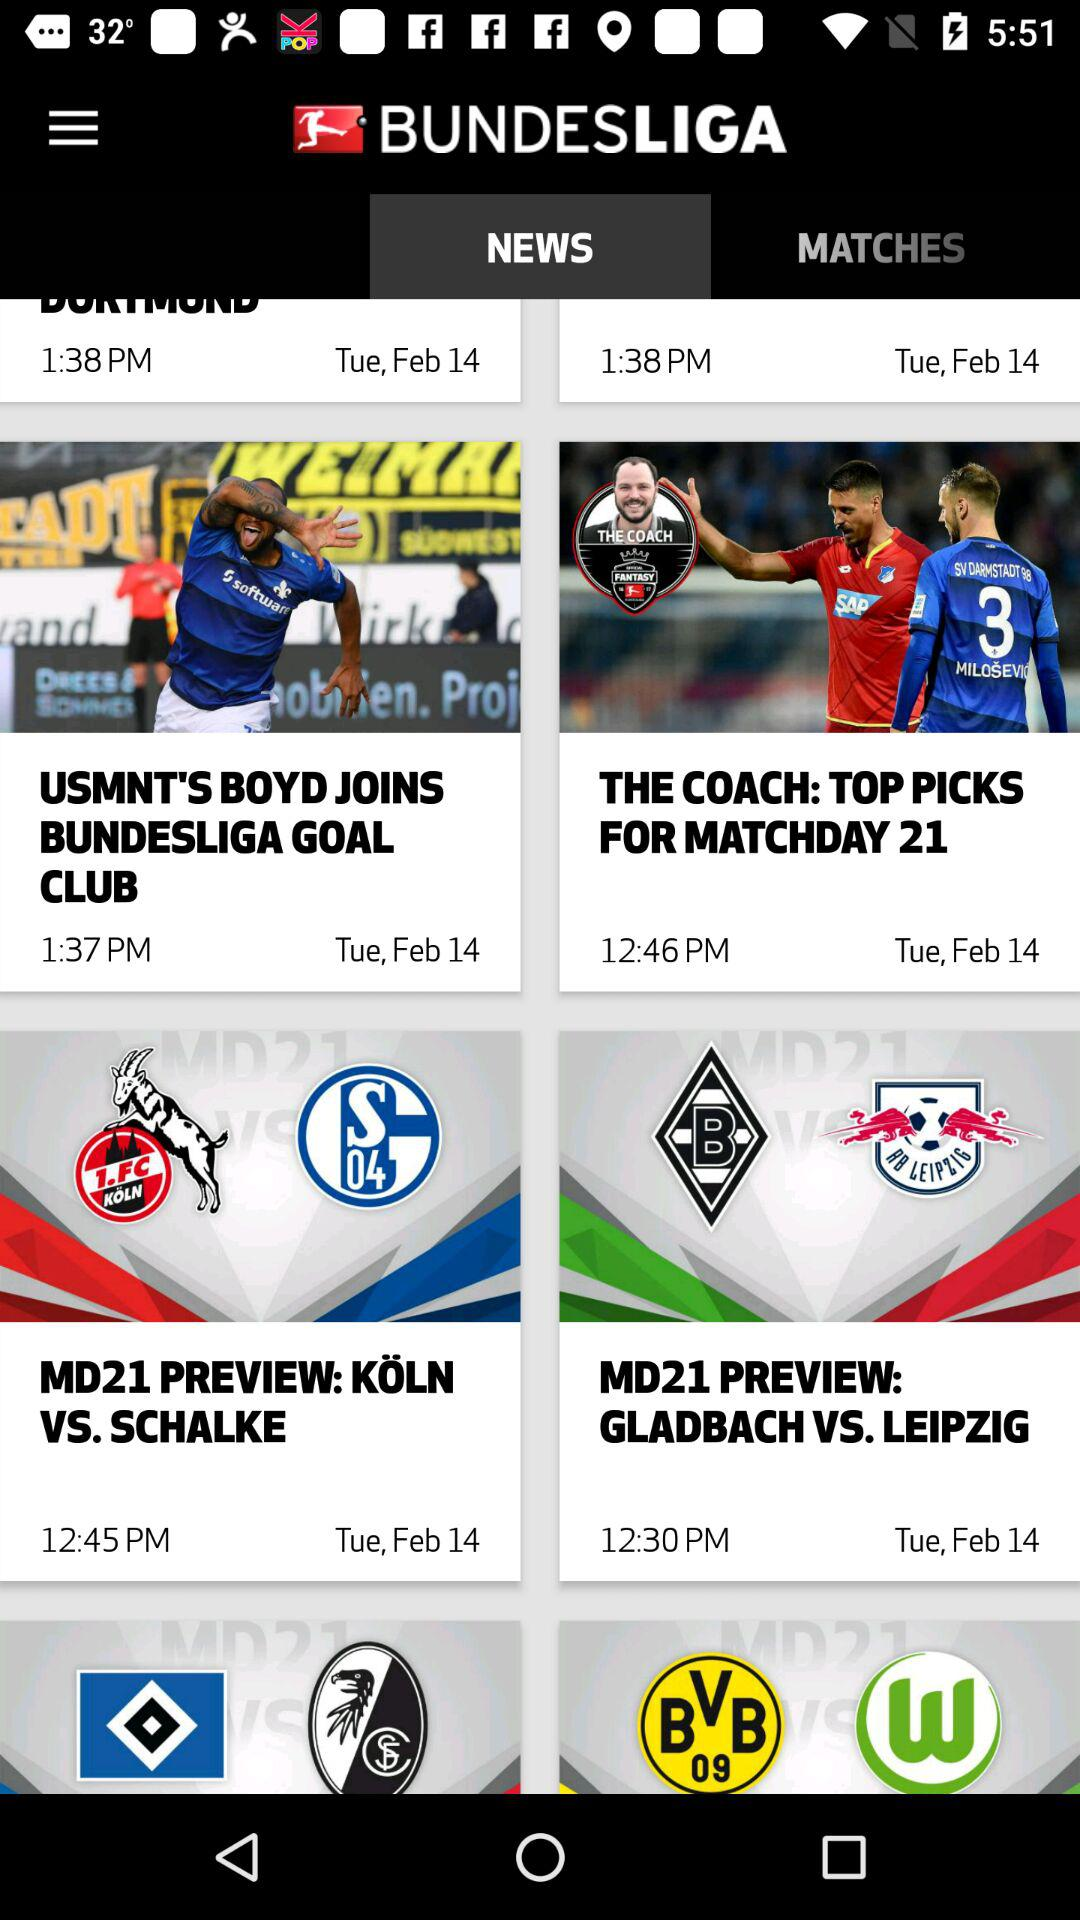Which news was published at 12:46 p.m.? The news published at 12:46 p.m. was "THE COACH: TOP PICKS FOR MATCHDAY 21". 